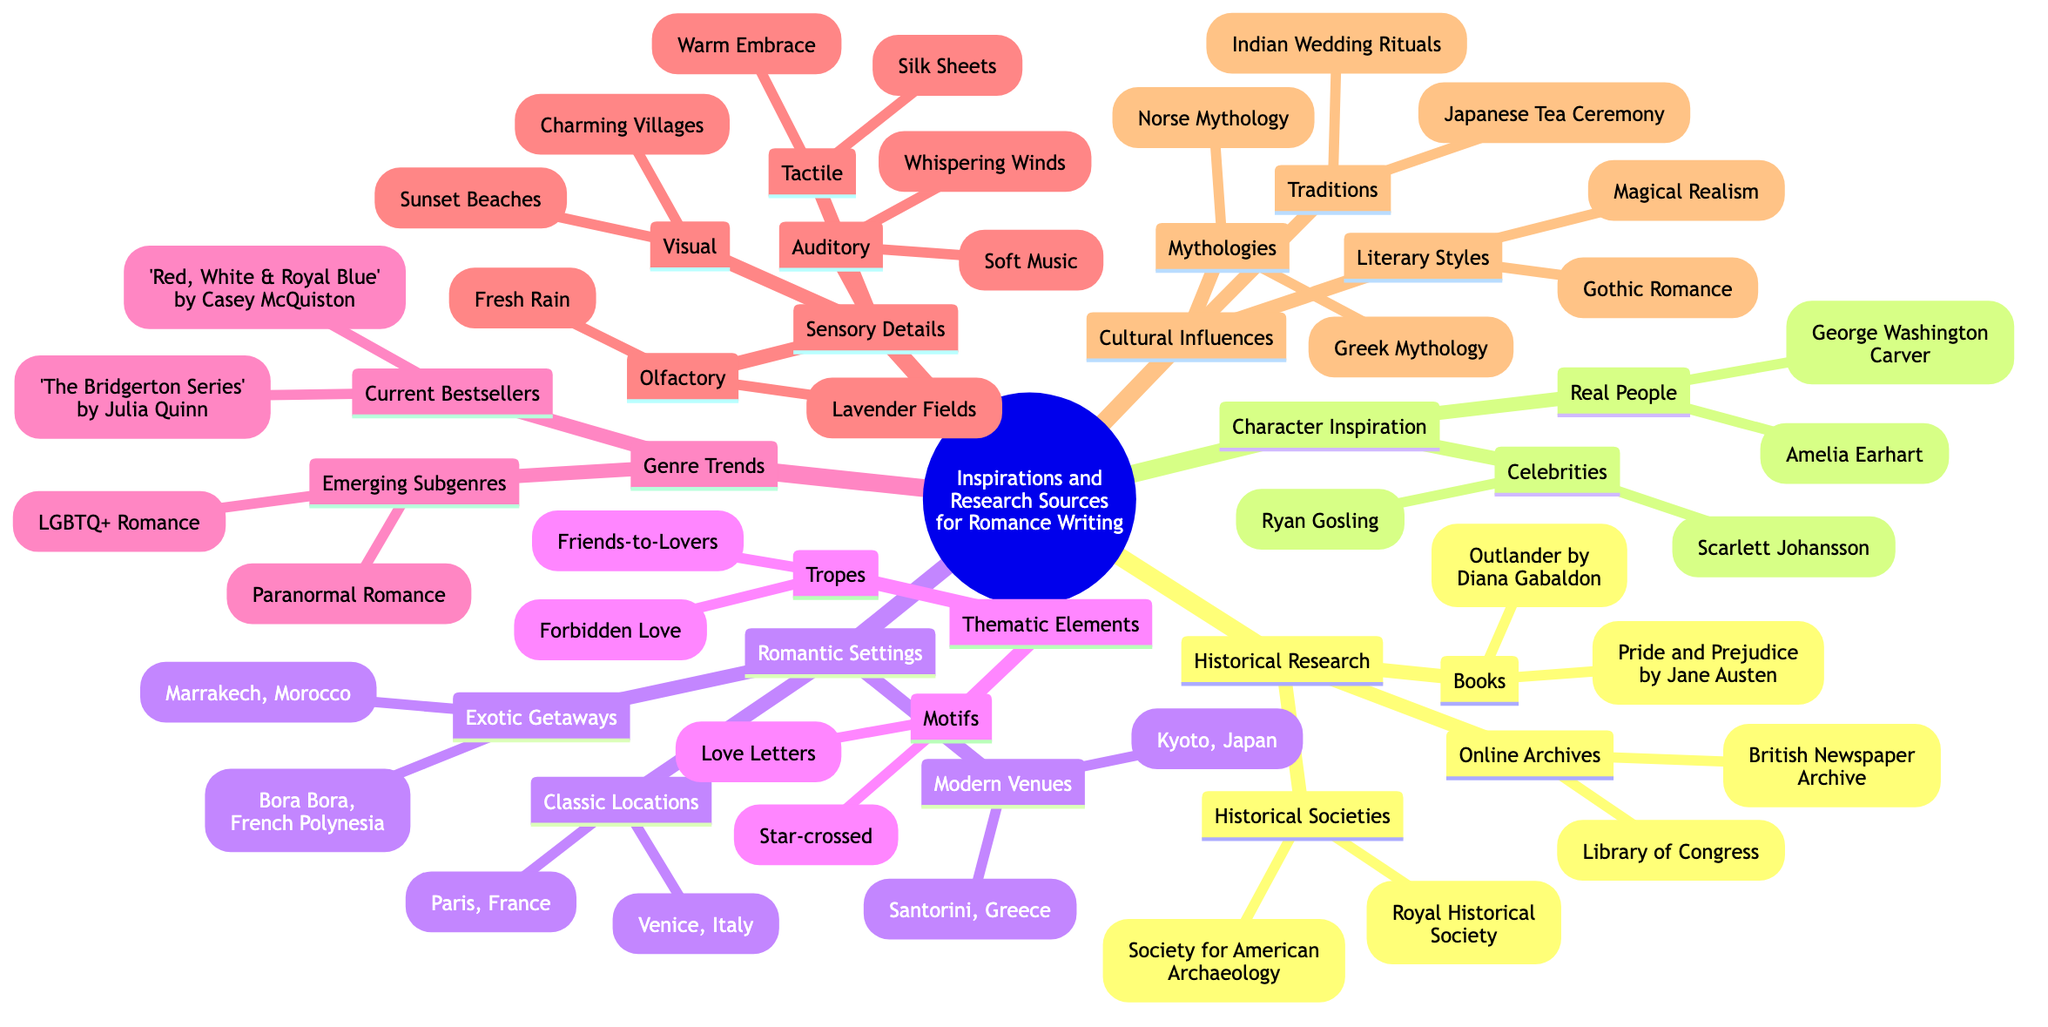What is one book listed under Historical Research? The diagram shows "Pride and Prejudice by Jane Austen" and "Outlander by Diana Gabaldon" under the Books category of Historical Research. Thus, selecting either of them answers the question.
Answer: Pride and Prejudice by Jane Austen How many types of Romantic Settings are listed? The Romantic Settings branch has three types: Classic Locations, Modern Venues, and Exotic Getaways. Therefore, counting these categories gives us the answer.
Answer: 3 Name a sensory detail related to Auditory. Looking under the Sensory Details section, there's an Auditory sub-category that lists "Whispering Winds" and "Soft Music." Either of these options would provide a valid answer to the question.
Answer: Whispering Winds Which thematic element includes "Forbidden Love"? "Forbidden Love" appears under the Tropes category within Thematic Elements. This can be directly referenced to provide a specific thematic element associated with romance.
Answer: Tropes What are the two emerging subgenres listed? The diagram mentions "Paranormal Romance" and "LGBTQ+ Romance" under the Emerging Subgenres in the Genre Trends section. Both titles are relevant to the question.
Answer: Paranormal Romance, LGBTQ+ Romance Which city is mentioned as a Classic Location? The diagram specifies "Paris, France" and "Venice, Italy" as Classic Locations under Romantic Settings. Thus, either of them can be mentioned in the answer.
Answer: Paris, France What mythical influence is listed under Cultural Influences? The Cultural Influences section under Mythologies includes "Greek Mythology" and "Norse Mythology." These are the specific influences mentioned in the diagram and can be readily stated.
Answer: Greek Mythology Name a celebrity listed under Character Inspiration. The Character Inspiration section has "Ryan Gosling" and "Scarlett Johansson" listed under Celebrities. Any of these names reflects the requested answer accurately.
Answer: Ryan Gosling 